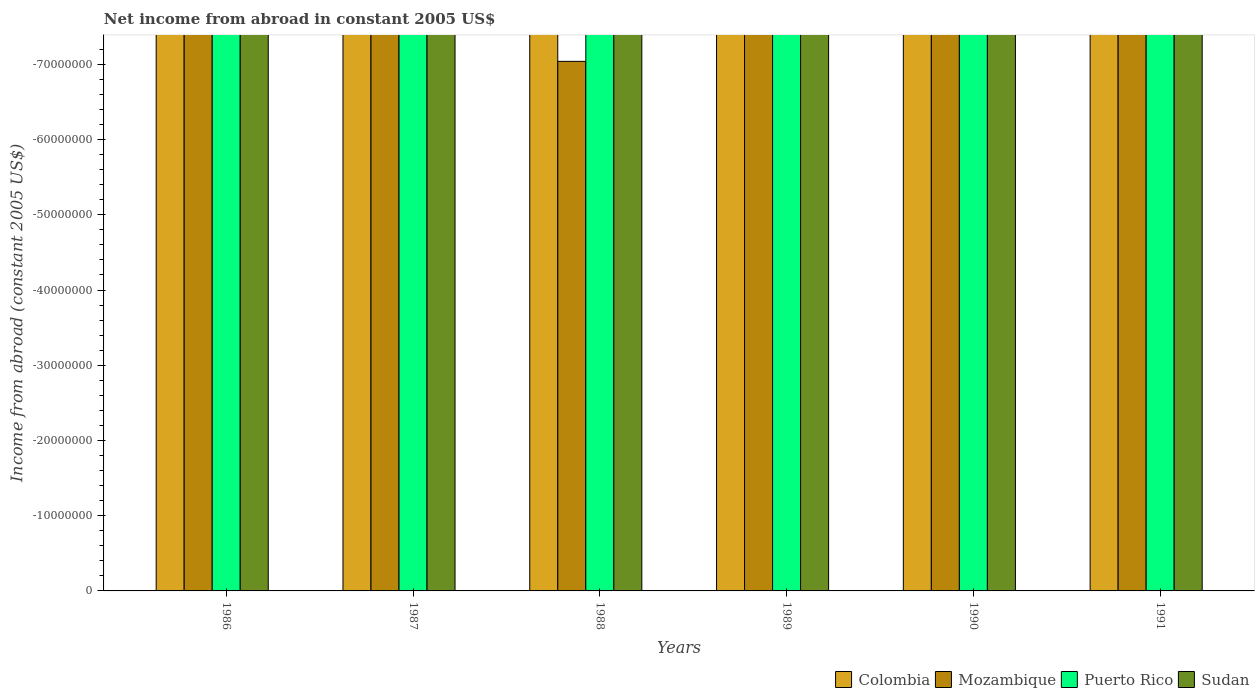How many different coloured bars are there?
Provide a succinct answer. 0. Are the number of bars per tick equal to the number of legend labels?
Provide a succinct answer. No. Are the number of bars on each tick of the X-axis equal?
Provide a succinct answer. Yes. How many bars are there on the 4th tick from the right?
Your answer should be compact. 0. What is the net income from abroad in Mozambique in 1991?
Give a very brief answer. 0. Across all years, what is the minimum net income from abroad in Mozambique?
Your answer should be compact. 0. What is the average net income from abroad in Puerto Rico per year?
Give a very brief answer. 0. Are all the bars in the graph horizontal?
Provide a succinct answer. No. How many years are there in the graph?
Make the answer very short. 6. What is the difference between two consecutive major ticks on the Y-axis?
Keep it short and to the point. 1.00e+07. Are the values on the major ticks of Y-axis written in scientific E-notation?
Provide a succinct answer. No. Does the graph contain any zero values?
Ensure brevity in your answer.  Yes. How are the legend labels stacked?
Ensure brevity in your answer.  Horizontal. What is the title of the graph?
Provide a succinct answer. Net income from abroad in constant 2005 US$. Does "Heavily indebted poor countries" appear as one of the legend labels in the graph?
Your answer should be very brief. No. What is the label or title of the X-axis?
Your answer should be compact. Years. What is the label or title of the Y-axis?
Offer a terse response. Income from abroad (constant 2005 US$). What is the Income from abroad (constant 2005 US$) in Mozambique in 1987?
Ensure brevity in your answer.  0. What is the Income from abroad (constant 2005 US$) in Sudan in 1988?
Your answer should be very brief. 0. What is the Income from abroad (constant 2005 US$) in Sudan in 1989?
Make the answer very short. 0. What is the Income from abroad (constant 2005 US$) of Mozambique in 1991?
Provide a short and direct response. 0. What is the Income from abroad (constant 2005 US$) of Puerto Rico in 1991?
Your answer should be very brief. 0. What is the Income from abroad (constant 2005 US$) of Sudan in 1991?
Provide a succinct answer. 0. What is the total Income from abroad (constant 2005 US$) of Puerto Rico in the graph?
Provide a short and direct response. 0. What is the average Income from abroad (constant 2005 US$) of Mozambique per year?
Ensure brevity in your answer.  0. What is the average Income from abroad (constant 2005 US$) in Puerto Rico per year?
Offer a terse response. 0. What is the average Income from abroad (constant 2005 US$) of Sudan per year?
Make the answer very short. 0. 